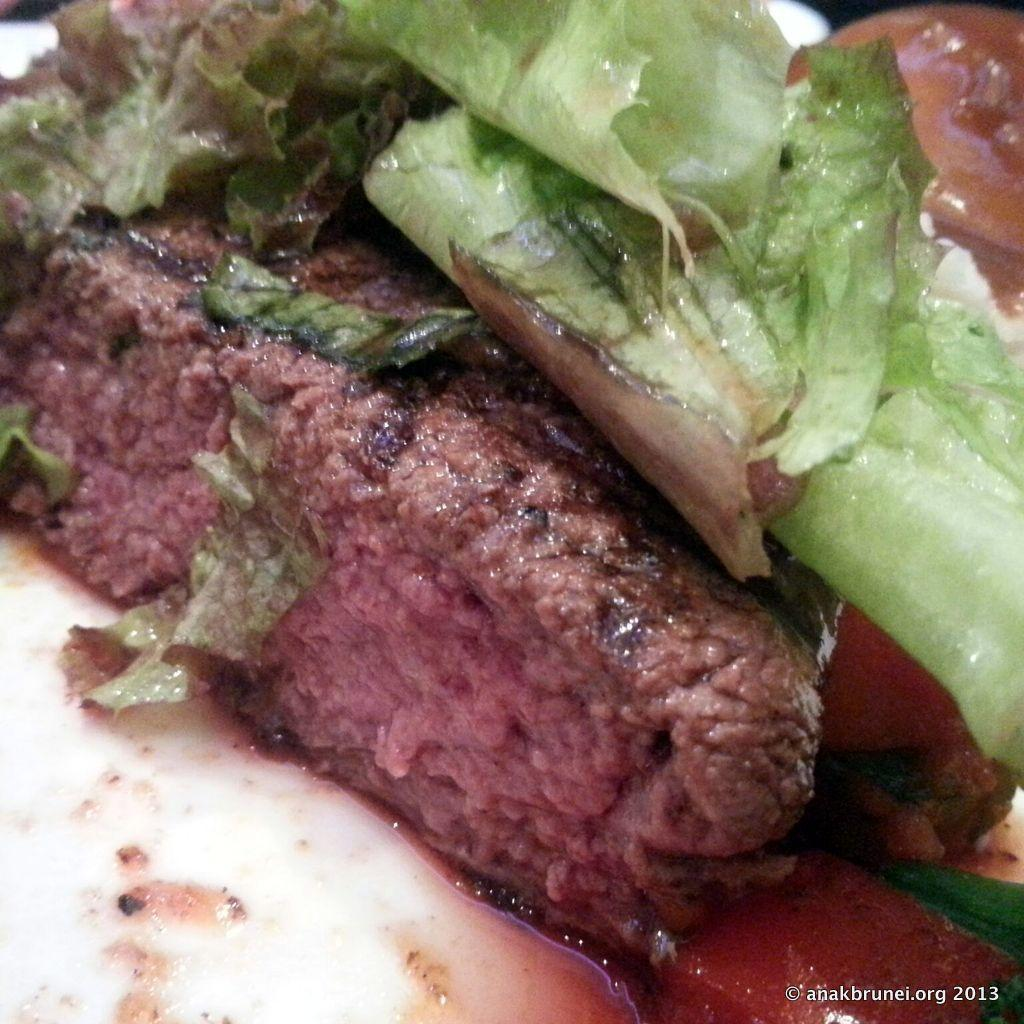What is the main subject of the image? The main subject of the image is food. How is the food arranged in the image? The food is in a plate. What type of food can be seen in the plate? There are leafy vegetables in the plate. What color is the plate? The plate is white. What hobbies does the father have in the image? There is no father or hobbies mentioned in the image; it only features food in a plate. Is there any smoke visible in the image? There is no smoke present in the image. 